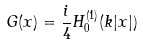Convert formula to latex. <formula><loc_0><loc_0><loc_500><loc_500>G ( x ) = { \frac { i } { 4 } } H _ { 0 } ^ { ( 1 ) } ( k | x | )</formula> 